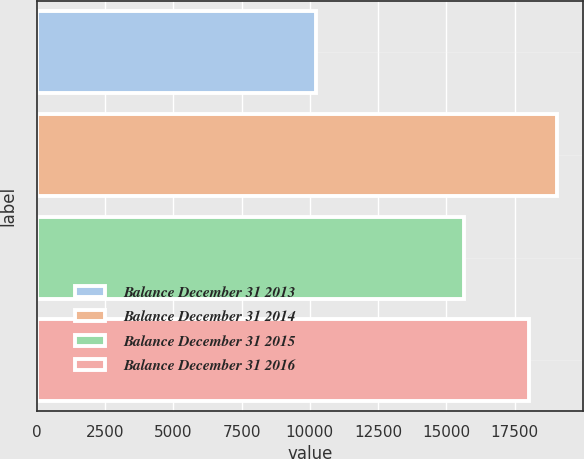Convert chart. <chart><loc_0><loc_0><loc_500><loc_500><bar_chart><fcel>Balance December 31 2013<fcel>Balance December 31 2014<fcel>Balance December 31 2015<fcel>Balance December 31 2016<nl><fcel>10231<fcel>19047<fcel>15627<fcel>18014<nl></chart> 